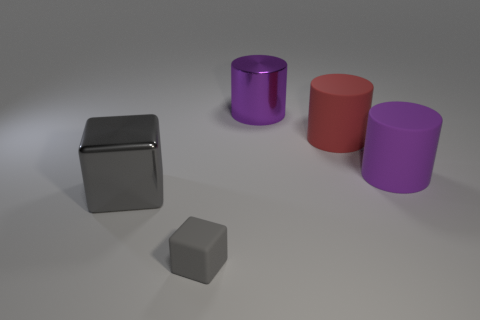Does the rubber block have the same color as the large cube?
Offer a very short reply. Yes. What material is the thing that is the same color as the big shiny cylinder?
Provide a short and direct response. Rubber. Is there a matte cube that has the same color as the shiny cube?
Your answer should be very brief. Yes. How many other objects are the same material as the large gray thing?
Provide a succinct answer. 1. There is a big metal cube; does it have the same color as the metal thing to the right of the small rubber cube?
Provide a succinct answer. No. Is the number of large things in front of the purple metal thing greater than the number of big purple things?
Provide a short and direct response. Yes. What number of metallic things are in front of the object on the right side of the big red cylinder behind the small thing?
Give a very brief answer. 1. Does the gray thing that is to the left of the small gray matte thing have the same shape as the red matte thing?
Provide a succinct answer. No. There is a cylinder to the right of the red object; what is its material?
Provide a short and direct response. Rubber. There is a large thing that is both left of the large red cylinder and behind the big gray metallic block; what shape is it?
Your answer should be very brief. Cylinder. 